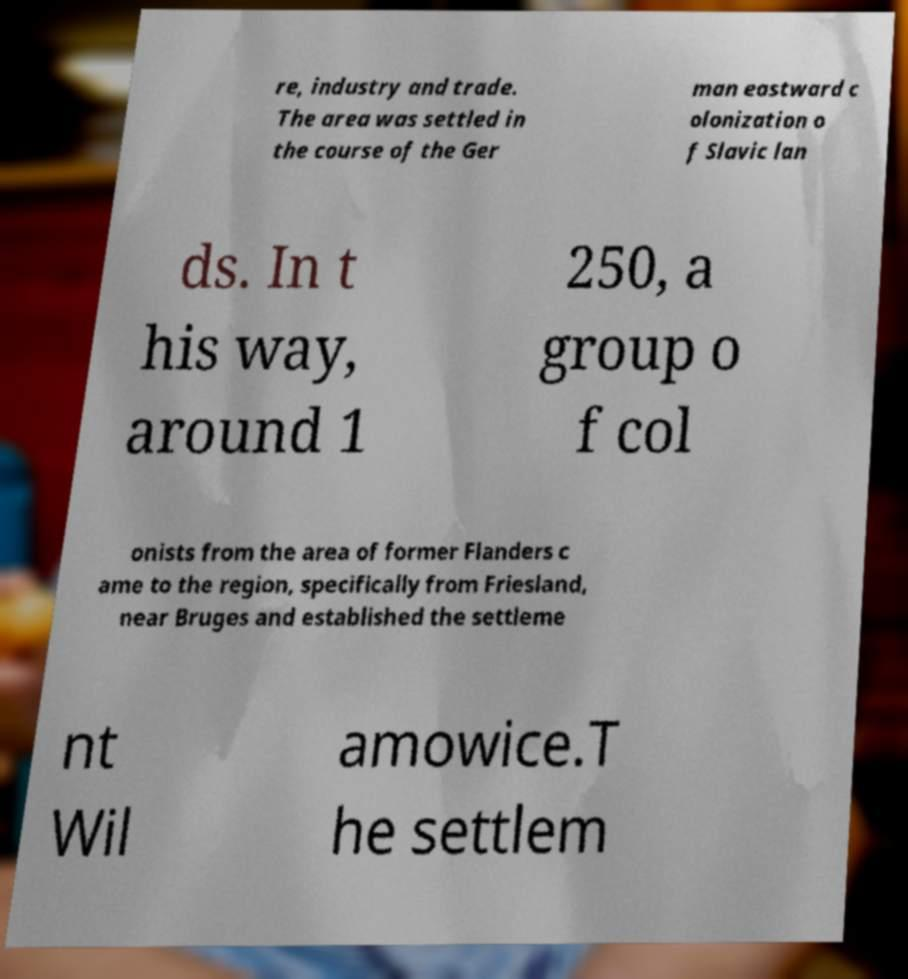Please identify and transcribe the text found in this image. re, industry and trade. The area was settled in the course of the Ger man eastward c olonization o f Slavic lan ds. In t his way, around 1 250, a group o f col onists from the area of former Flanders c ame to the region, specifically from Friesland, near Bruges and established the settleme nt Wil amowice.T he settlem 